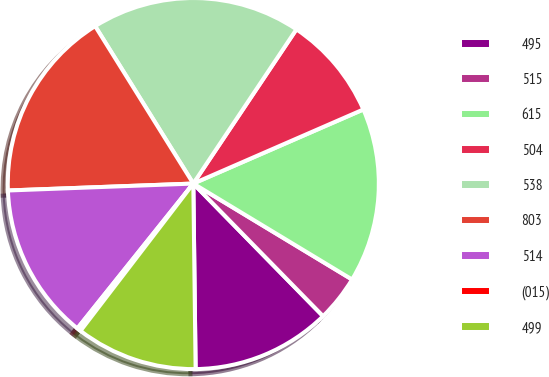<chart> <loc_0><loc_0><loc_500><loc_500><pie_chart><fcel>495<fcel>515<fcel>615<fcel>504<fcel>538<fcel>803<fcel>514<fcel>(015)<fcel>499<nl><fcel>12.13%<fcel>4.02%<fcel>15.19%<fcel>9.08%<fcel>18.25%<fcel>16.72%<fcel>13.66%<fcel>0.34%<fcel>10.6%<nl></chart> 